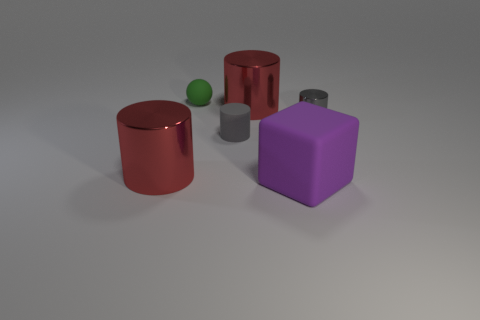Is there anything else that is the same size as the purple matte object?
Give a very brief answer. Yes. Is the small metal cylinder the same color as the small rubber cylinder?
Make the answer very short. Yes. There is a red thing that is right of the large shiny cylinder left of the small green thing; what is its material?
Your response must be concise. Metal. What number of big cylinders are left of the big object that is in front of the big shiny cylinder that is in front of the tiny gray rubber cylinder?
Your answer should be compact. 2. Are the cylinder that is left of the ball and the green object that is behind the purple matte block made of the same material?
Offer a terse response. No. What is the material of the other small thing that is the same color as the tiny shiny thing?
Give a very brief answer. Rubber. How many large red things are the same shape as the tiny gray matte thing?
Your answer should be very brief. 2. Are there more large purple blocks that are in front of the tiny rubber sphere than small green cylinders?
Your answer should be compact. Yes. There is a large red thing that is on the left side of the big red object that is behind the large red cylinder left of the green matte ball; what shape is it?
Your answer should be very brief. Cylinder. There is a large red object behind the tiny metallic cylinder; is its shape the same as the tiny gray object that is right of the big rubber thing?
Offer a terse response. Yes. 